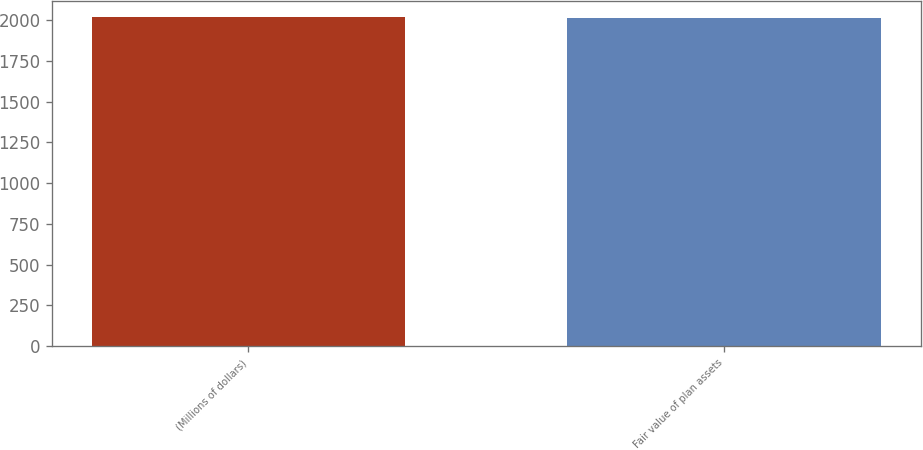<chart> <loc_0><loc_0><loc_500><loc_500><bar_chart><fcel>(Millions of dollars)<fcel>Fair value of plan assets<nl><fcel>2018<fcel>2012<nl></chart> 